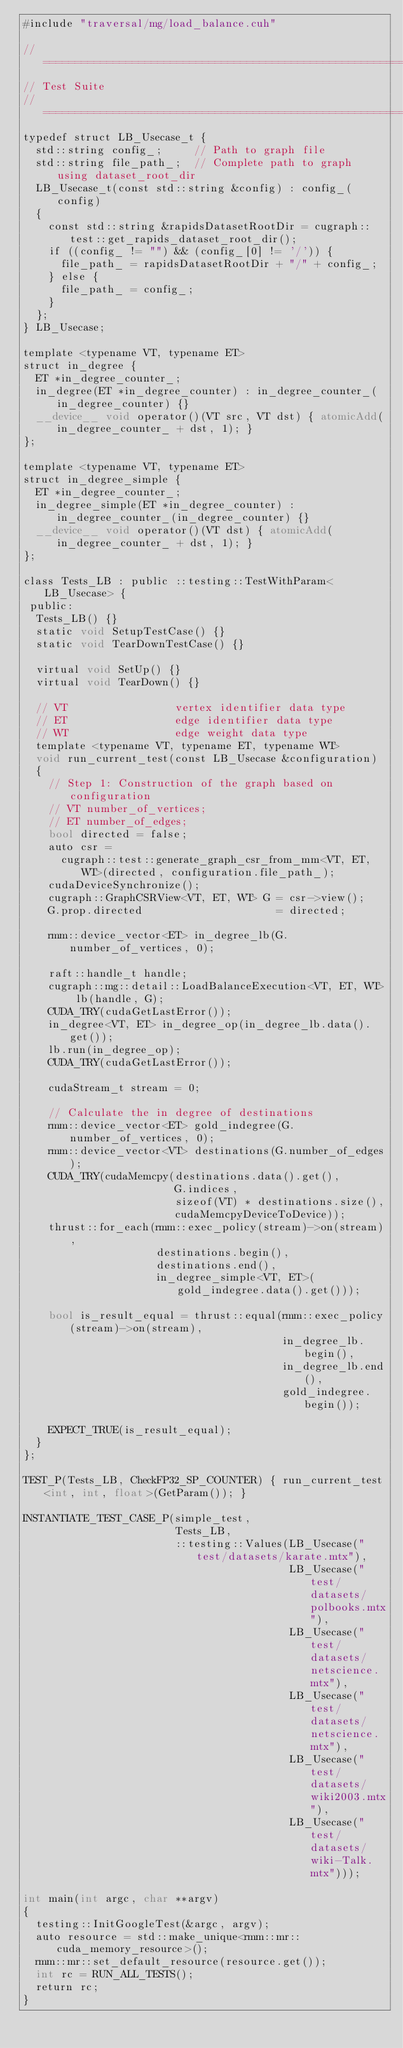<code> <loc_0><loc_0><loc_500><loc_500><_Cuda_>#include "traversal/mg/load_balance.cuh"

// ============================================================================
// Test Suite
// ============================================================================
typedef struct LB_Usecase_t {
  std::string config_;     // Path to graph file
  std::string file_path_;  // Complete path to graph using dataset_root_dir
  LB_Usecase_t(const std::string &config) : config_(config)
  {
    const std::string &rapidsDatasetRootDir = cugraph::test::get_rapids_dataset_root_dir();
    if ((config_ != "") && (config_[0] != '/')) {
      file_path_ = rapidsDatasetRootDir + "/" + config_;
    } else {
      file_path_ = config_;
    }
  };
} LB_Usecase;

template <typename VT, typename ET>
struct in_degree {
  ET *in_degree_counter_;
  in_degree(ET *in_degree_counter) : in_degree_counter_(in_degree_counter) {}
  __device__ void operator()(VT src, VT dst) { atomicAdd(in_degree_counter_ + dst, 1); }
};

template <typename VT, typename ET>
struct in_degree_simple {
  ET *in_degree_counter_;
  in_degree_simple(ET *in_degree_counter) : in_degree_counter_(in_degree_counter) {}
  __device__ void operator()(VT dst) { atomicAdd(in_degree_counter_ + dst, 1); }
};

class Tests_LB : public ::testing::TestWithParam<LB_Usecase> {
 public:
  Tests_LB() {}
  static void SetupTestCase() {}
  static void TearDownTestCase() {}

  virtual void SetUp() {}
  virtual void TearDown() {}

  // VT                 vertex identifier data type
  // ET                 edge identifier data type
  // WT                 edge weight data type
  template <typename VT, typename ET, typename WT>
  void run_current_test(const LB_Usecase &configuration)
  {
    // Step 1: Construction of the graph based on configuration
    // VT number_of_vertices;
    // ET number_of_edges;
    bool directed = false;
    auto csr =
      cugraph::test::generate_graph_csr_from_mm<VT, ET, WT>(directed, configuration.file_path_);
    cudaDeviceSynchronize();
    cugraph::GraphCSRView<VT, ET, WT> G = csr->view();
    G.prop.directed                     = directed;

    rmm::device_vector<ET> in_degree_lb(G.number_of_vertices, 0);

    raft::handle_t handle;
    cugraph::mg::detail::LoadBalanceExecution<VT, ET, WT> lb(handle, G);
    CUDA_TRY(cudaGetLastError());
    in_degree<VT, ET> in_degree_op(in_degree_lb.data().get());
    lb.run(in_degree_op);
    CUDA_TRY(cudaGetLastError());

    cudaStream_t stream = 0;

    // Calculate the in degree of destinations
    rmm::device_vector<ET> gold_indegree(G.number_of_vertices, 0);
    rmm::device_vector<VT> destinations(G.number_of_edges);
    CUDA_TRY(cudaMemcpy(destinations.data().get(),
                        G.indices,
                        sizeof(VT) * destinations.size(),
                        cudaMemcpyDeviceToDevice));
    thrust::for_each(rmm::exec_policy(stream)->on(stream),
                     destinations.begin(),
                     destinations.end(),
                     in_degree_simple<VT, ET>(gold_indegree.data().get()));

    bool is_result_equal = thrust::equal(rmm::exec_policy(stream)->on(stream),
                                         in_degree_lb.begin(),
                                         in_degree_lb.end(),
                                         gold_indegree.begin());

    EXPECT_TRUE(is_result_equal);
  }
};

TEST_P(Tests_LB, CheckFP32_SP_COUNTER) { run_current_test<int, int, float>(GetParam()); }

INSTANTIATE_TEST_CASE_P(simple_test,
                        Tests_LB,
                        ::testing::Values(LB_Usecase("test/datasets/karate.mtx"),
                                          LB_Usecase("test/datasets/polbooks.mtx"),
                                          LB_Usecase("test/datasets/netscience.mtx"),
                                          LB_Usecase("test/datasets/netscience.mtx"),
                                          LB_Usecase("test/datasets/wiki2003.mtx"),
                                          LB_Usecase("test/datasets/wiki-Talk.mtx")));

int main(int argc, char **argv)
{
  testing::InitGoogleTest(&argc, argv);
  auto resource = std::make_unique<rmm::mr::cuda_memory_resource>();
  rmm::mr::set_default_resource(resource.get());
  int rc = RUN_ALL_TESTS();
  return rc;
}
</code> 